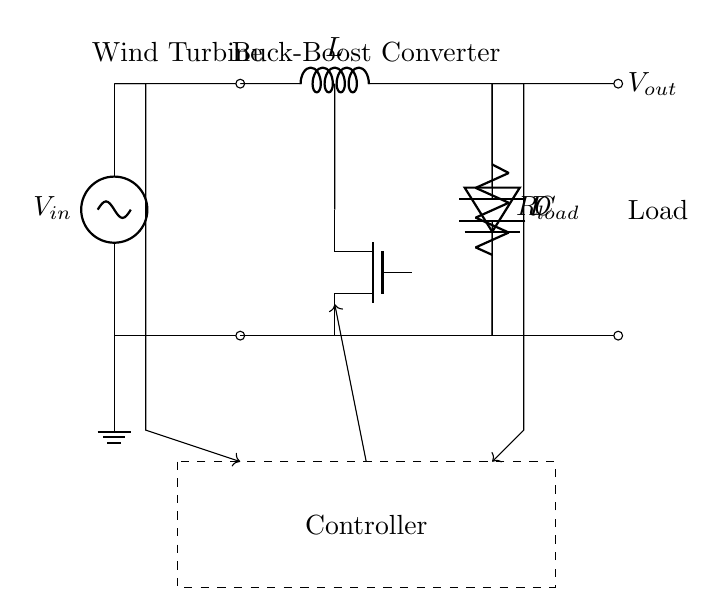What is the type of converter shown in the circuit? The circuit depicts a buck-boost converter, which is indicated by the arrangement of the inductor, capacitor, and the switching element (MOSFET), allowing the output voltage to be either higher or lower than the input voltage.
Answer: Buck-boost converter What component regulates the voltage in this circuit? The regulator in the circuit is represented by the MOSFET, which switches on and off to control the voltage output based on the input voltage and load requirements, helping to maintain the desired output voltage level.
Answer: MOSFET What is the function of the inductor in this circuit? The inductor stores energy when the MOSFET is on and releases energy when the MOSFET is off, smoothing out voltage variations and contributing to the energy conversion process inherent to the buck-boost function.
Answer: Energy storage What happens to the output voltage when the input voltage increases? When the input voltage increases, the output voltage can also increase due to the buck-boost converter's ability to step up the voltage, maintaining a stable output to the load under varying input conditions.
Answer: Increases Which component would you adjust to change the output voltage level? The output voltage level can be changed by adjusting the duty cycle of the MOSFET's operation through the controller, which directly influences how long the MOSFET is in the ON state compared to the OFF state.
Answer: Controller How does the load affect current in the circuit? The load determines the amount of current drawn from the output; higher resistance in the load results in lower current, while lower resistance increases current flow, impacting the voltage regulation achieved by the converter.
Answer: Affects current draw What is the role of the capacitor in this buck-boost converter? The capacitor smooths the output voltage by filtering out ripples and providing a reservoir of charge to maintain voltage stability during fluctuating load conditions and switching behavior of the converter.
Answer: Voltage smoothing 